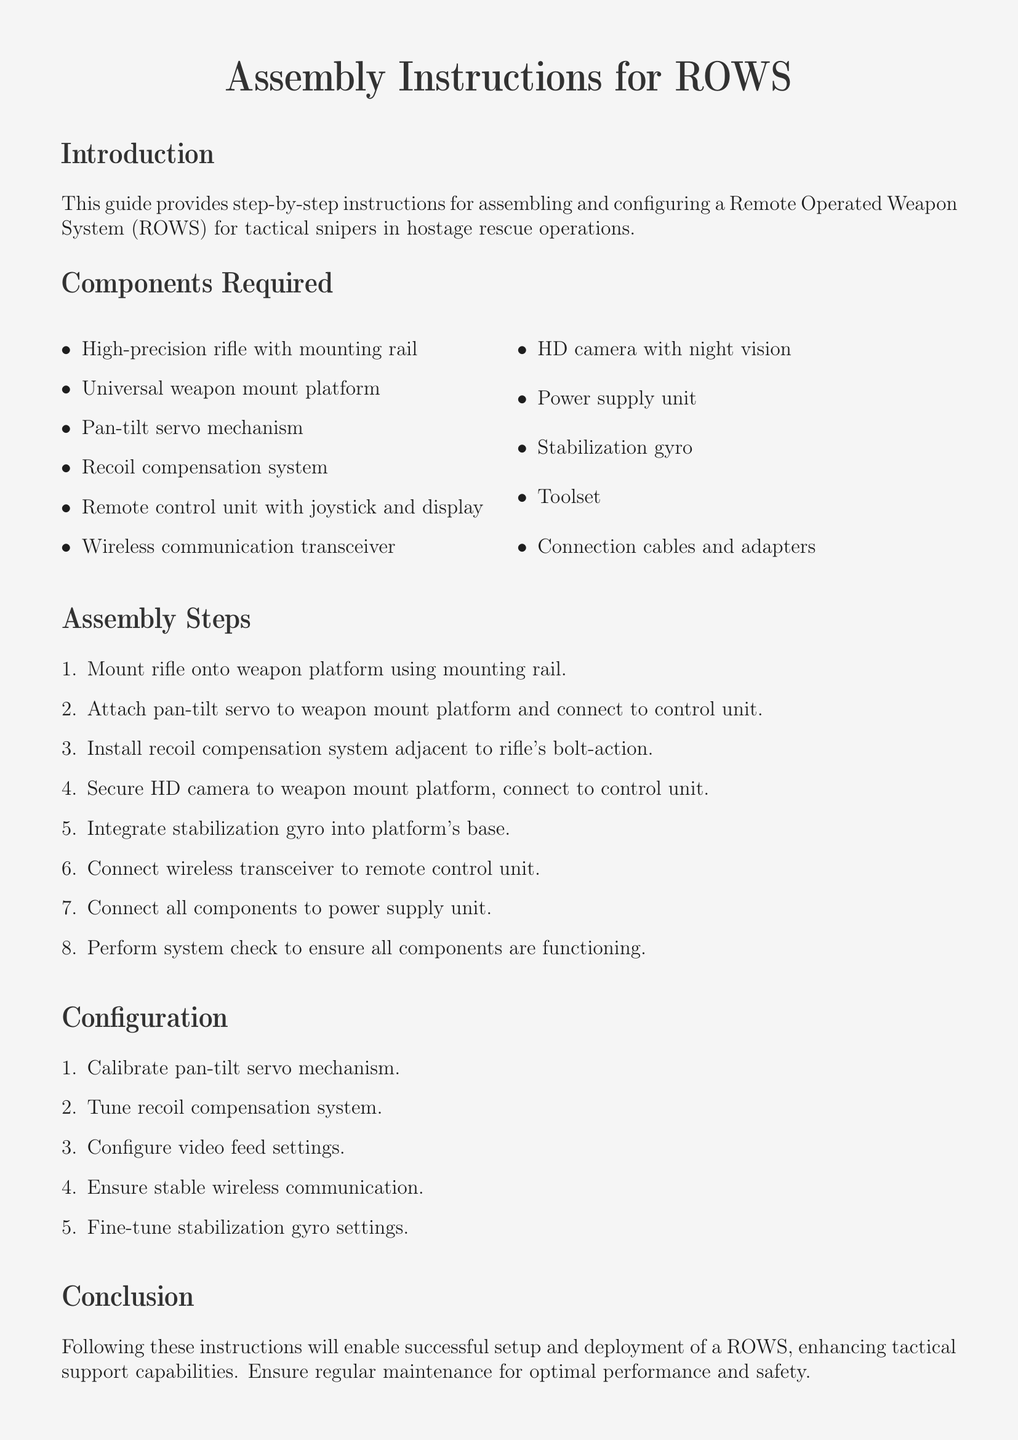What is the primary purpose of the guide? The introduction states that the guide provides instructions for assembling and configuring a Remote Operated Weapon System for tactical snipers in hostage rescue operations.
Answer: hostage rescue operations How many components are listed in the document? The list of required components details a total of eleven items that are necessary for assembly.
Answer: eleven What type of mechanism is used for camera movement? The assembly steps mention the attachment of a pan-tilt servo mechanism, indicating the type of movement system used.
Answer: pan-tilt servo mechanism What is the first step in the assembly process? The first item listed in the assembly steps indicates the first action to take when beginning the assembly process.
Answer: Mount rifle onto weapon platform Which component is used for stabilization? The configuration section indicates that a stabilization gyro is integrated into the platform to enhance stability.
Answer: stabilization gyro What is necessary to ensure stable wireless communication? The configuration section mentions the requirement for tuning or configuring specific settings to ensure communication stability.
Answer: Ensure stable wireless communication What is the role of the recoil compensation system? The assembly steps show the positioning of the recoil compensation system in relation to the rifle and explain its function.
Answer: Adjacent to rifle's bolt-action How should the components be connected for operation? The assembly steps describe the connection process to the power supply and outline the general connection method for operation.
Answer: Connect all components to power supply unit What is the last action listed in the assembly steps? The last enumeration in the assembly steps indicates the final check that should be conducted after assembly.
Answer: Perform system check 